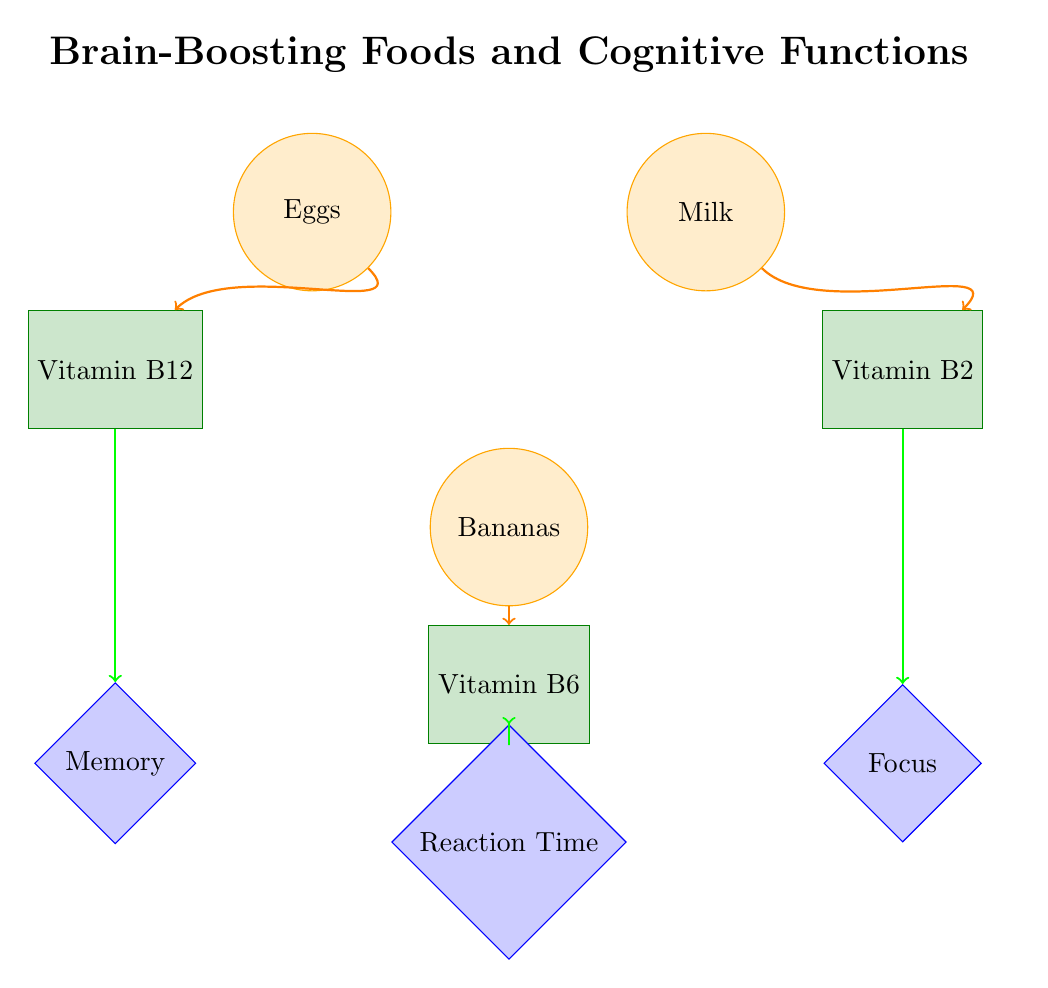what foods are linked to Vitamin B12 in the diagram? The diagram shows a direct link from "Eggs" to "Vitamin B12" with an arrow indicating a connection. Since no other food source is associated with Vitamin B12, Eggs is the only food linked to it.
Answer: Eggs which cognitive function is associated with Vitamin B2? From the diagram, Vitamin B2 has an arrow pointing towards "Focus." This indicates that Vitamin B2 is directly linked to enhancing focus, answering the question.
Answer: Focus how many nodes are categorized under Cognitive Functions? The diagram features three diamond-shaped nodes labeled: "Memory," "Focus," and "Reaction Time." Counting these gives a total of three nodes in the Cognitive Functions category.
Answer: 3 which food is related to Reaction Time? According to the diagram, "Bananas" is connected to "Vitamin B6," which then connects to "Reaction Time." The relationship shows that Bananas are acknowledged for their contribution to reaction time.
Answer: Bananas is there a food linked to both a nutrient and a cognitive function? Yes, in this diagram, "Vitamin B12" is linked to both "Eggs" (food) and "Memory" (cognitive function), showcasing a direct relationship between the two categories through a nutrient.
Answer: Yes which nutrient is related to Bananas? The diagram shows a direct arrow going from "Bananas" to "Vitamin B6," indicating that Bananas are associated with this nutrient. Thus, Vitamin B6 is the answer here.
Answer: Vitamin B6 what is the total number of edges in the diagram? The diagram includes six directed links (edges) that connect the food items to nutrients and nutrients to cognitive functions. Counting these provides a total of six edges in the diagram.
Answer: 6 which food is connected to the cognitive function of Memory? The relationship in the diagram indicates an arrow from "Vitamin B12" to "Memory." Given that "Vitamin B12" is connected to "Eggs," it carries the link to the cognitive function of Memory. The food that ultimately informs Memory is Eggs.
Answer: Eggs 